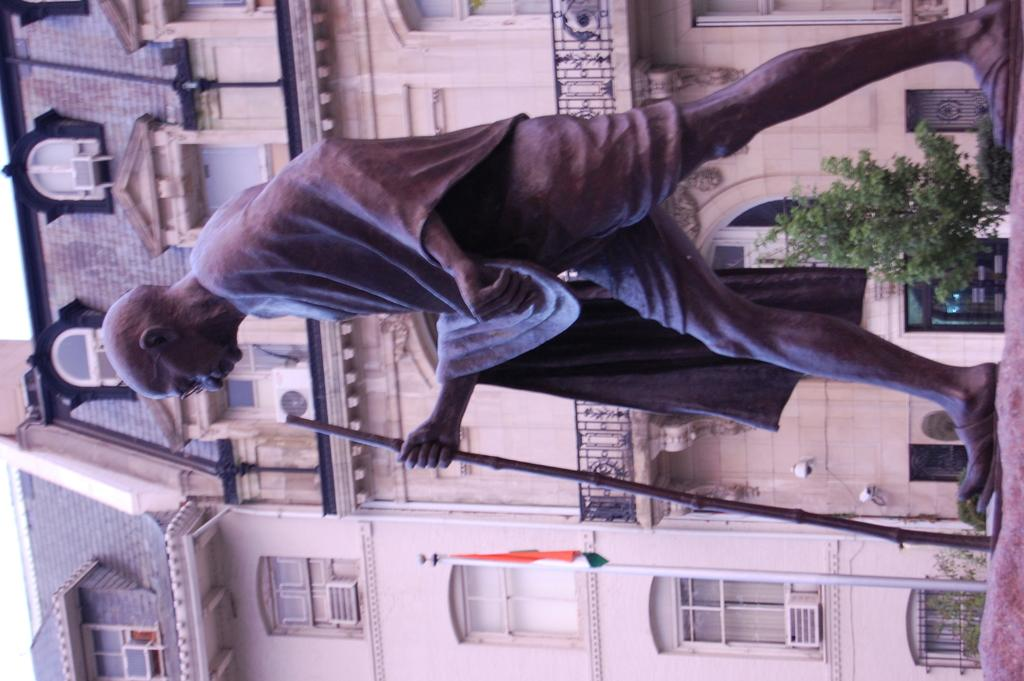What is the main subject of the image? There is a statue of Mahatma Gandhi in the image. What can be seen behind the statue? There are plants behind the statue. What structure is visible in the image? There is a building visible in the image. What is located in front of the building? There is a flag in front of the building. What type of iron is used to make the hospital in the image? There is no hospital present in the image, and therefore no iron can be associated with it. 